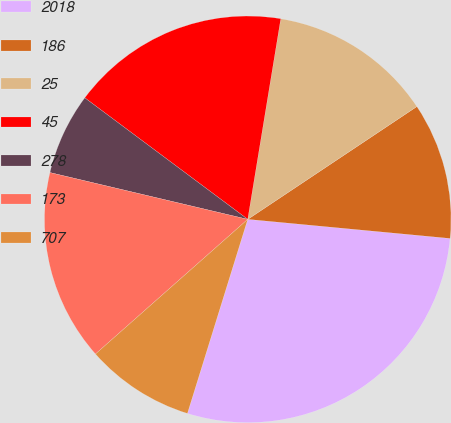Convert chart to OTSL. <chart><loc_0><loc_0><loc_500><loc_500><pie_chart><fcel>2018<fcel>186<fcel>25<fcel>45<fcel>278<fcel>173<fcel>707<nl><fcel>28.29%<fcel>10.86%<fcel>13.04%<fcel>17.4%<fcel>6.5%<fcel>15.22%<fcel>8.68%<nl></chart> 